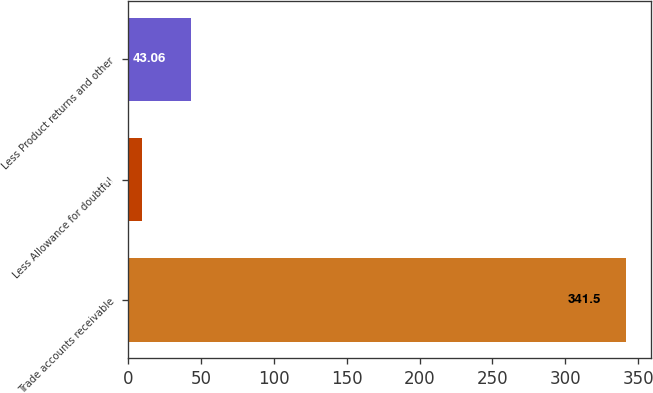Convert chart to OTSL. <chart><loc_0><loc_0><loc_500><loc_500><bar_chart><fcel>Trade accounts receivable<fcel>Less Allowance for doubtful<fcel>Less Product returns and other<nl><fcel>341.5<fcel>9.9<fcel>43.06<nl></chart> 